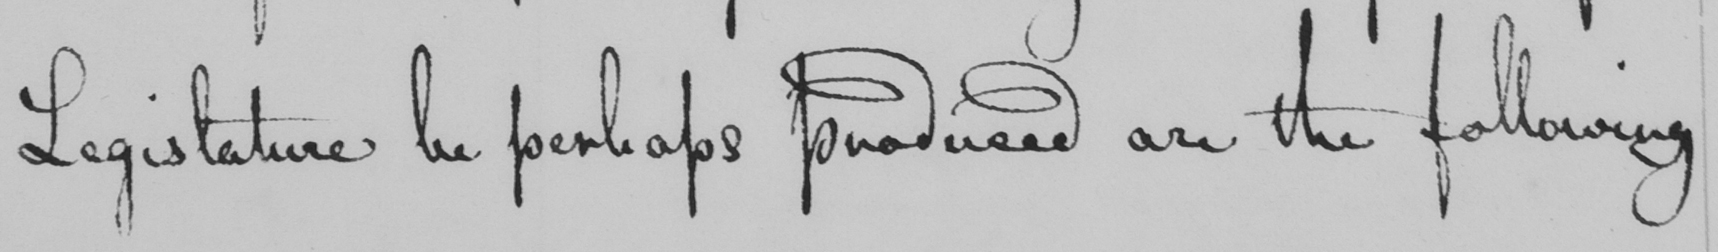What does this handwritten line say? Legislature be perhaps produced are the following 